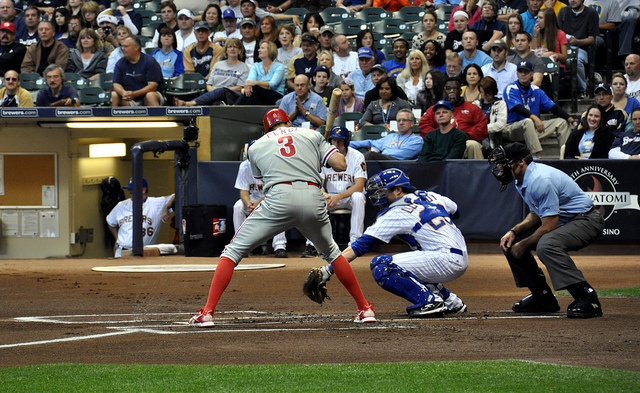Describe the objects in this image and their specific colors. I can see people in lavender, black, gray, darkgray, and maroon tones, people in lavender, black, lightgray, navy, and gray tones, people in lavender, darkgray, lightgray, black, and gray tones, people in lavender, black, and gray tones, and people in lavender, black, and darkgray tones in this image. 